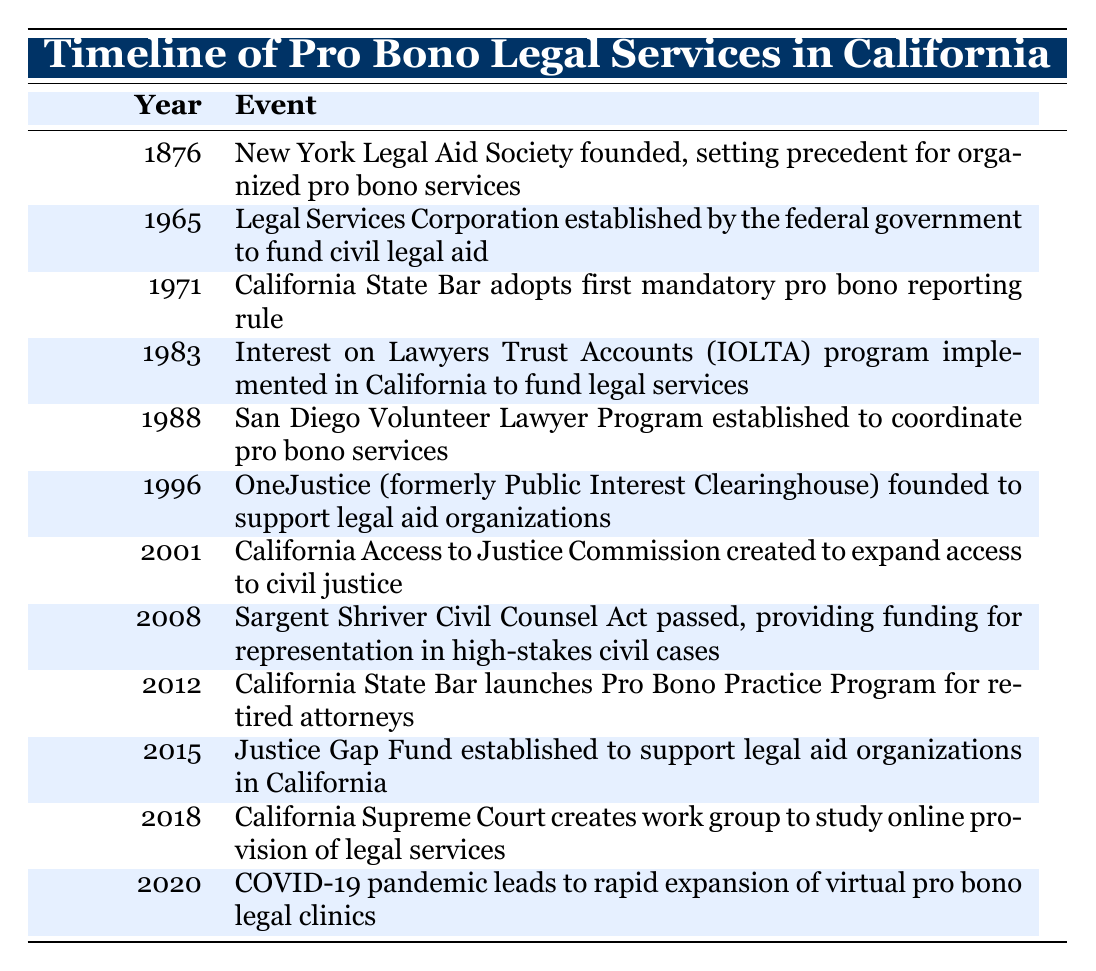What year was the California Access to Justice Commission created? The table lists the events by year, and for the California Access to Justice Commission, the entry shows the year as 2001.
Answer: 2001 What event occurred in 1983? By looking at the table, the event noted for 1983 is the implementation of the Interest on Lawyers Trust Accounts (IOLTA) program in California.
Answer: Interest on Lawyers Trust Accounts (IOLTA) program implemented in California to fund legal services Was the Sargent Shriver Civil Counsel Act passed before 2010? The table indicates that the Sargent Shriver Civil Counsel Act was passed in 2008, which is indeed before 2010.
Answer: Yes How many events are listed between 1971 and 1996? The events between 1971 and 1996 include 1971, 1983, 1988, and 1996, totaling four distinct events.
Answer: 4 Which decade saw the establishment of the San Diego Volunteer Lawyer Program? The San Diego Volunteer Lawyer Program was established in 1988, which falls within the 1980s.
Answer: 1980s What is the difference in years between the founding of OneJustice and the establishment of the California Access to Justice Commission? OneJustice was founded in 1996, and the California Access to Justice Commission was established in 2001. Calculating the difference: 2001 - 1996 = 5 years.
Answer: 5 years Did any events related to pro bono legal services occur during the COVID-19 pandemic? Yes, the table mentions that in 2020, the COVID-19 pandemic led to a rapid expansion of virtual pro bono legal clinics.
Answer: Yes What was the first initiative mentioned in the timeline that specifically targeted retired attorneys? The first initiative for retired attorneys mentioned in the table is the Pro Bono Practice Program, which was launched in 2012.
Answer: Pro Bono Practice Program What key change happened to pro bono services in California from 2008 to 2015? Between 2008 and 2015, the Justice Gap Fund was established in 2015 to support legal aid organizations, indicating a focus on funding legal services.
Answer: Justice Gap Fund established 